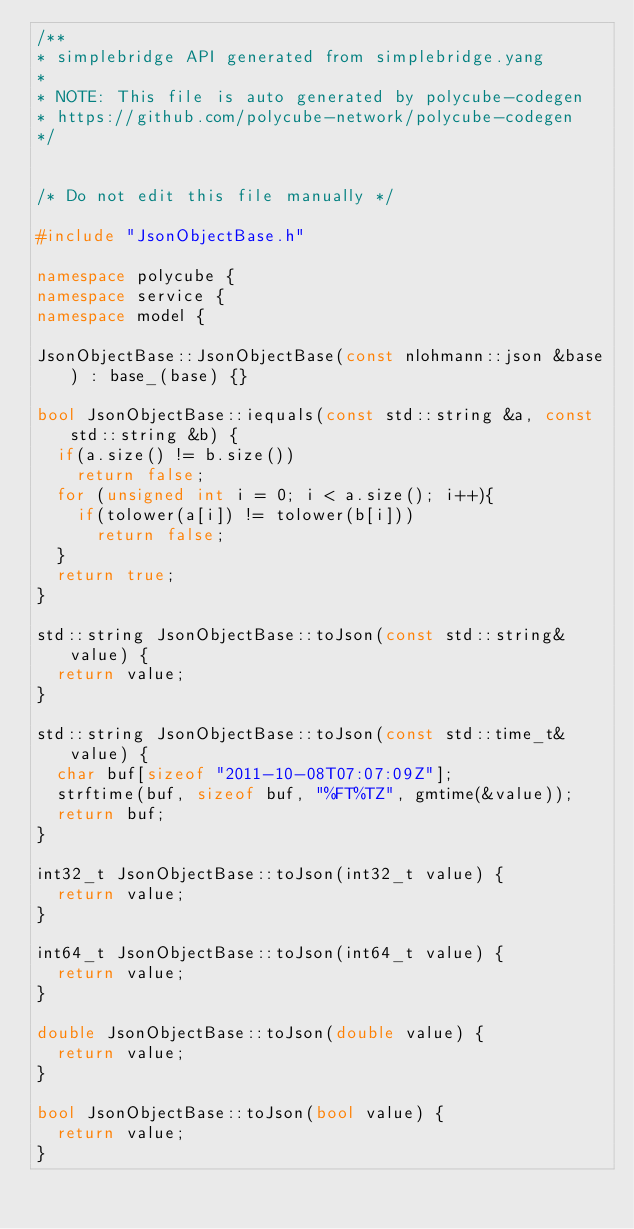Convert code to text. <code><loc_0><loc_0><loc_500><loc_500><_C++_>/**
* simplebridge API generated from simplebridge.yang
*
* NOTE: This file is auto generated by polycube-codegen
* https://github.com/polycube-network/polycube-codegen
*/


/* Do not edit this file manually */

#include "JsonObjectBase.h"

namespace polycube {
namespace service {
namespace model {

JsonObjectBase::JsonObjectBase(const nlohmann::json &base) : base_(base) {}

bool JsonObjectBase::iequals(const std::string &a, const std::string &b) {
  if(a.size() != b.size())
    return false;
  for (unsigned int i = 0; i < a.size(); i++){
    if(tolower(a[i]) != tolower(b[i]))
      return false;
  }
  return true;
}

std::string JsonObjectBase::toJson(const std::string& value) {
  return value;
}

std::string JsonObjectBase::toJson(const std::time_t& value) {
  char buf[sizeof "2011-10-08T07:07:09Z"];
  strftime(buf, sizeof buf, "%FT%TZ", gmtime(&value));
  return buf;
}

int32_t JsonObjectBase::toJson(int32_t value) {
  return value;
}

int64_t JsonObjectBase::toJson(int64_t value) {
  return value;
}

double JsonObjectBase::toJson(double value) {
  return value;
}

bool JsonObjectBase::toJson(bool value) {
  return value;
}
</code> 